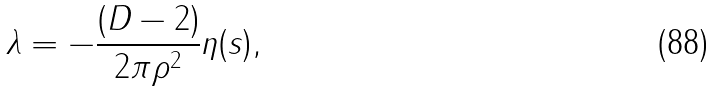Convert formula to latex. <formula><loc_0><loc_0><loc_500><loc_500>\lambda = - \frac { ( D - 2 ) } { 2 \pi \rho ^ { 2 } } \eta ( s ) ,</formula> 